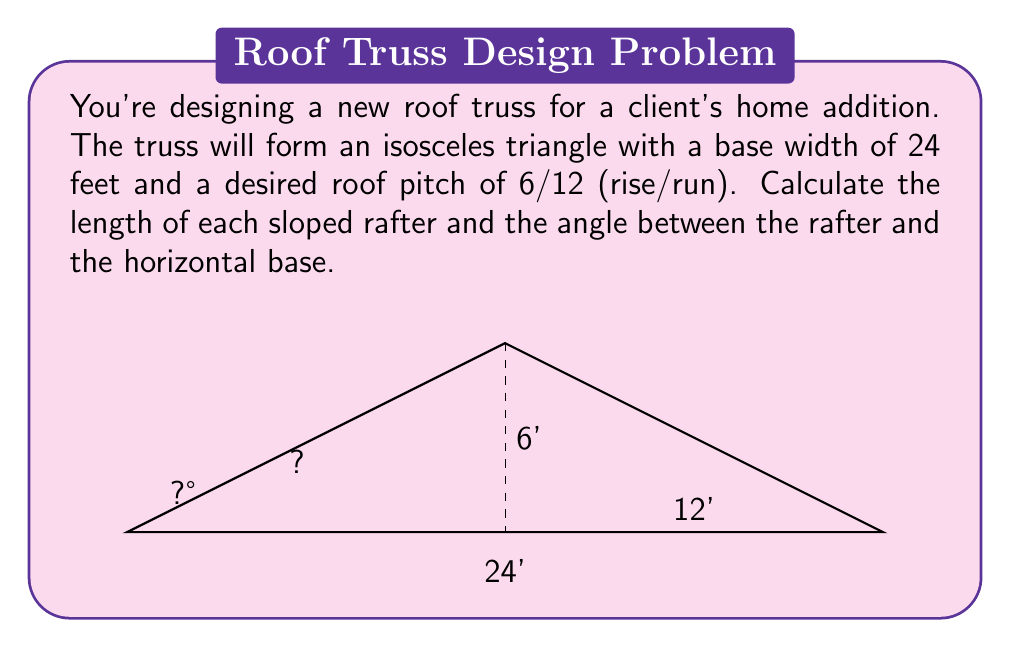Help me with this question. Let's approach this step-by-step:

1) First, we need to understand the given information:
   - Base width = 24 feet
   - Pitch = 6/12 (rise/run)

2) The pitch tells us that for every 12 horizontal feet, the roof rises 6 feet.

3) Since the base is 24 feet, and the truss is an isosceles triangle, the peak will be at the midpoint (12 feet).

4) Now we can find the height of the triangle:
   $$ \text{Height} = \frac{6}{12} \times 12 = 6 \text{ feet} $$

5) To find the length of the rafter, we can use the Pythagorean theorem:
   $$ \text{Rafter}^2 = 12^2 + 6^2 $$
   $$ \text{Rafter}^2 = 144 + 36 = 180 $$
   $$ \text{Rafter} = \sqrt{180} = 6\sqrt{5} \approx 13.42 \text{ feet} $$

6) To find the angle between the rafter and the horizontal base, we can use the inverse tangent function:
   $$ \theta = \tan^{-1}\left(\frac{6}{12}\right) = \tan^{-1}\left(\frac{1}{2}\right) \approx 26.57° $$

Therefore, each rafter is approximately 13.42 feet long, and the angle between the rafter and the horizontal base is approximately 26.57°.
Answer: Rafter length: $6\sqrt{5}$ ft (≈13.42 ft). Angle: $\tan^{-1}(\frac{1}{2})° $ (≈26.57°). 